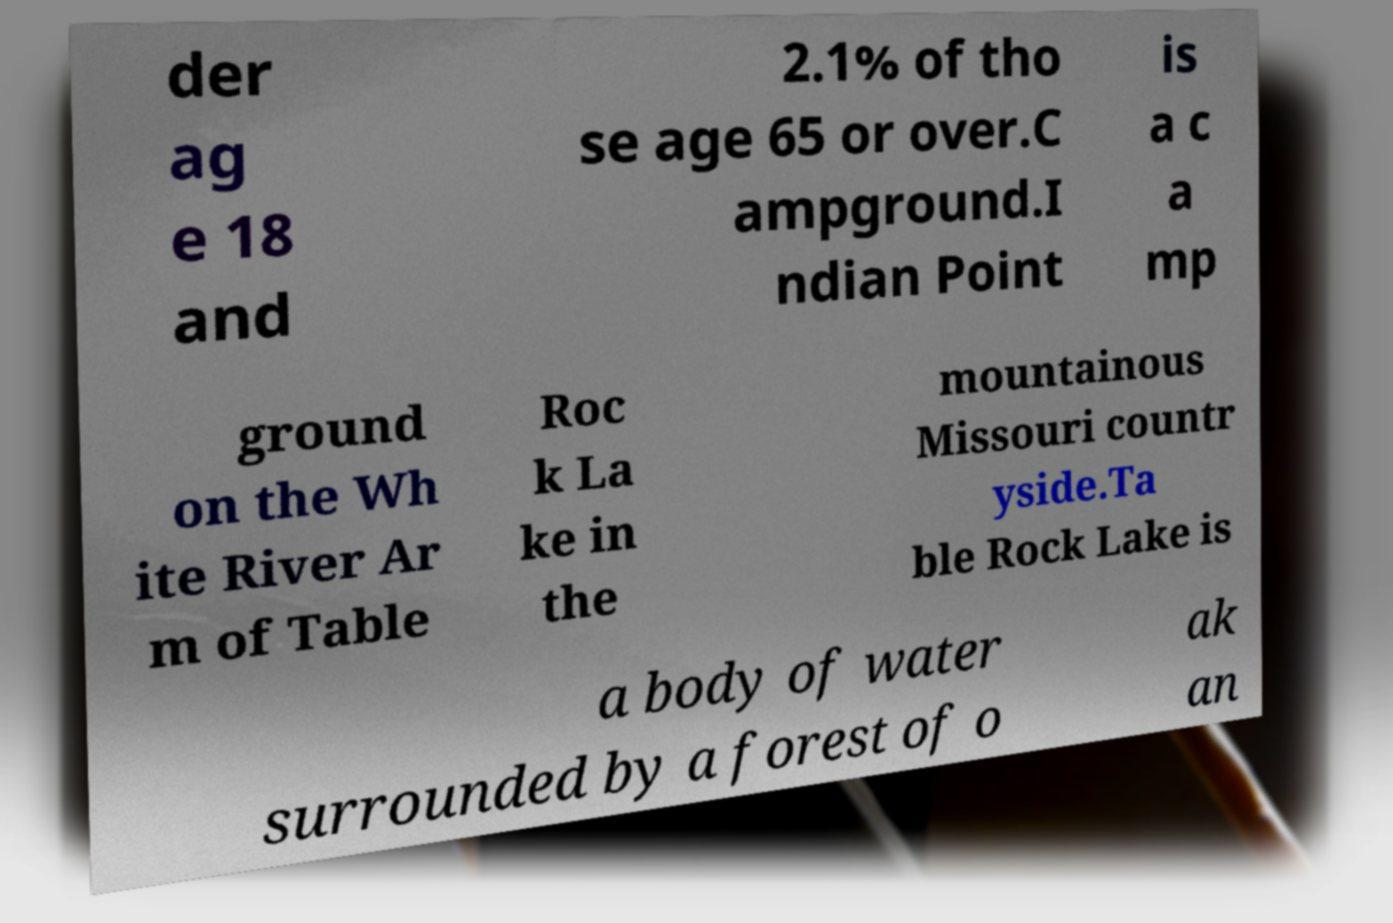Please identify and transcribe the text found in this image. der ag e 18 and 2.1% of tho se age 65 or over.C ampground.I ndian Point is a c a mp ground on the Wh ite River Ar m of Table Roc k La ke in the mountainous Missouri countr yside.Ta ble Rock Lake is a body of water surrounded by a forest of o ak an 